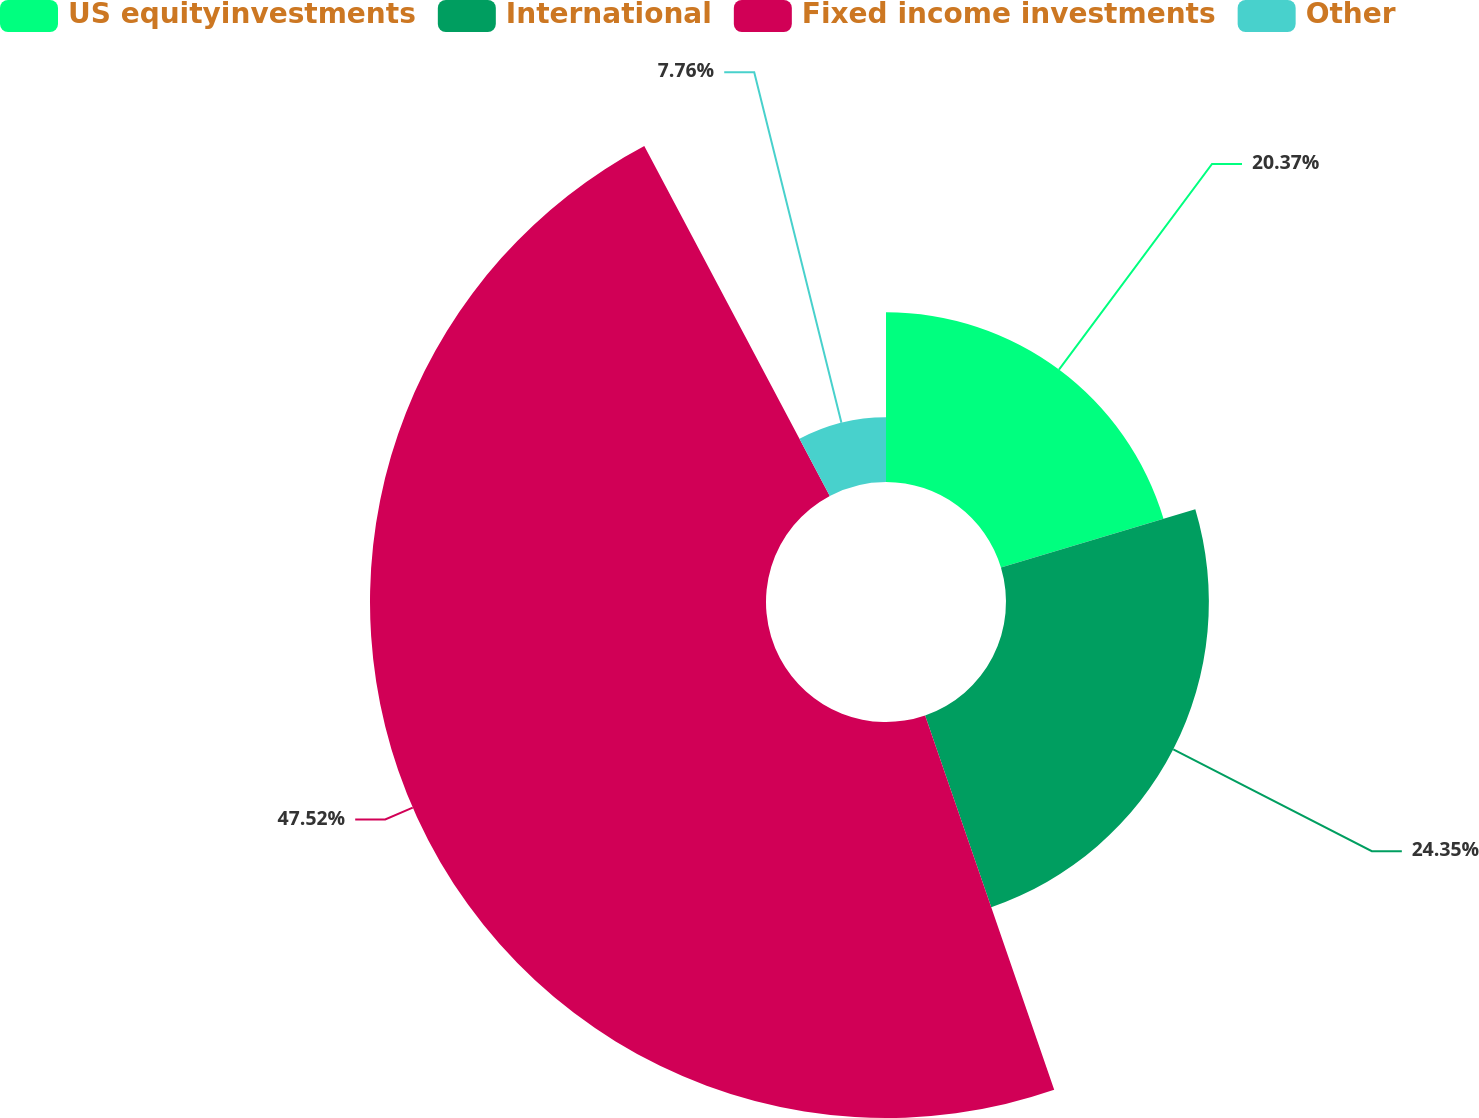Convert chart to OTSL. <chart><loc_0><loc_0><loc_500><loc_500><pie_chart><fcel>US equityinvestments<fcel>International<fcel>Fixed income investments<fcel>Other<nl><fcel>20.37%<fcel>24.35%<fcel>47.53%<fcel>7.76%<nl></chart> 